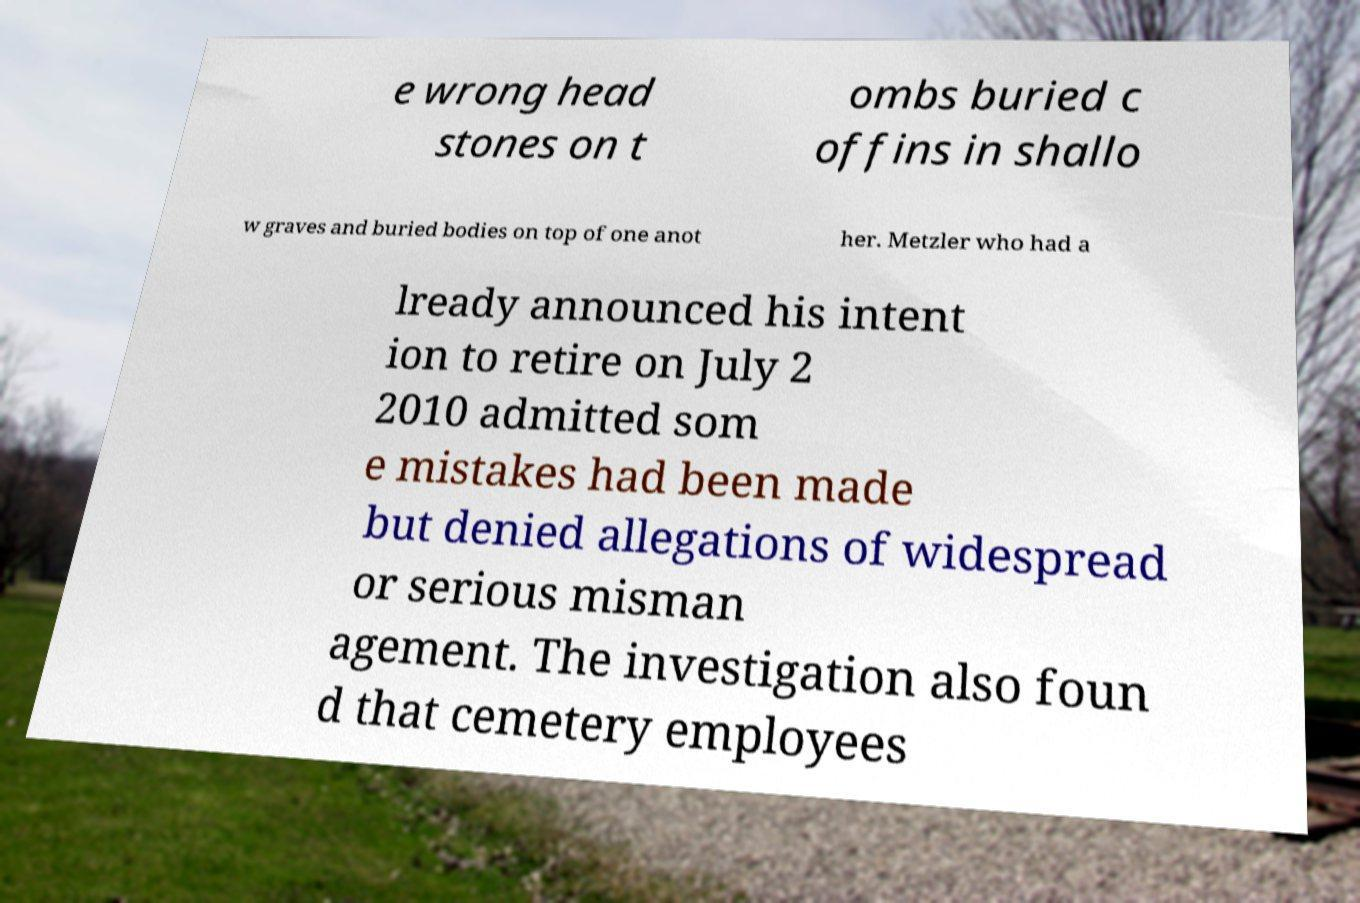Please identify and transcribe the text found in this image. e wrong head stones on t ombs buried c offins in shallo w graves and buried bodies on top of one anot her. Metzler who had a lready announced his intent ion to retire on July 2 2010 admitted som e mistakes had been made but denied allegations of widespread or serious misman agement. The investigation also foun d that cemetery employees 